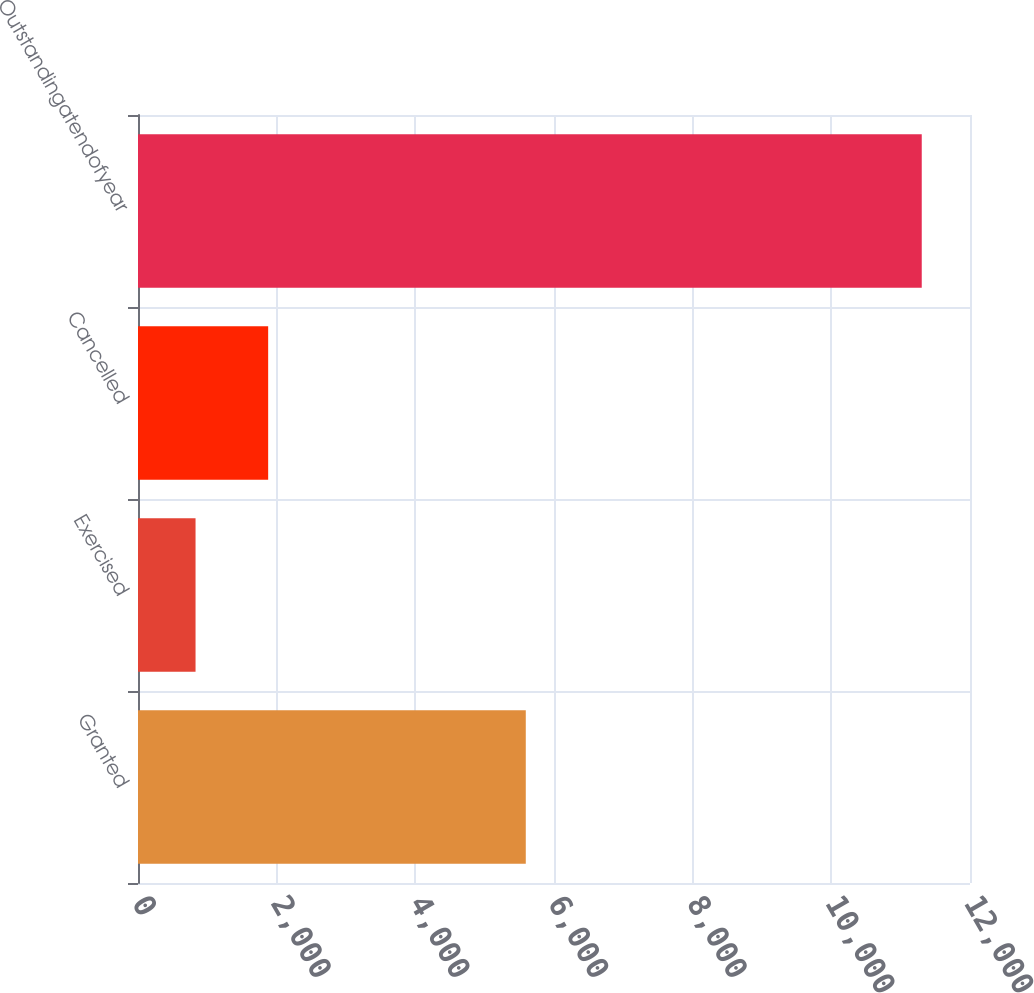Convert chart to OTSL. <chart><loc_0><loc_0><loc_500><loc_500><bar_chart><fcel>Granted<fcel>Exercised<fcel>Cancelled<fcel>Outstandingatendofyear<nl><fcel>5593<fcel>830<fcel>1877.4<fcel>11304<nl></chart> 